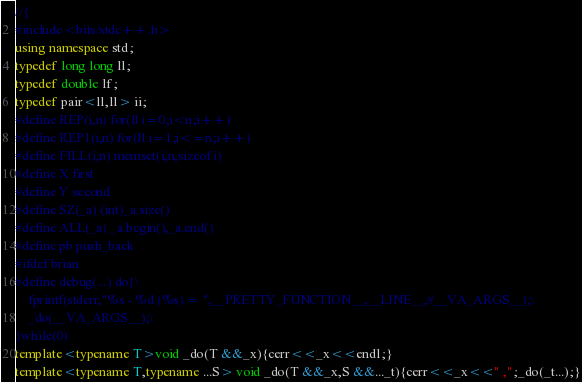Convert code to text. <code><loc_0><loc_0><loc_500><loc_500><_C++_>//{
#include<bits/stdc++.h>
using namespace std;
typedef long long ll;
typedef double lf;
typedef pair<ll,ll> ii;
#define REP(i,n) for(ll i=0;i<n;i++)
#define REP1(i,n) for(ll i=1;i<=n;i++)
#define FILL(i,n) memset(i,n,sizeof i)
#define X first
#define Y second
#define SZ(_a) (int)_a.size()
#define ALL(_a) _a.begin(),_a.end()
#define pb push_back
#ifdef brian
#define debug(...) do{\
    fprintf(stderr,"%s - %d (%s) = ",__PRETTY_FUNCTION__,__LINE__,#__VA_ARGS__);\
    _do(__VA_ARGS__);\
}while(0)
template<typename T>void _do(T &&_x){cerr<<_x<<endl;}
template<typename T,typename ...S> void _do(T &&_x,S &&..._t){cerr<<_x<<" ,";_do(_t...);}</code> 